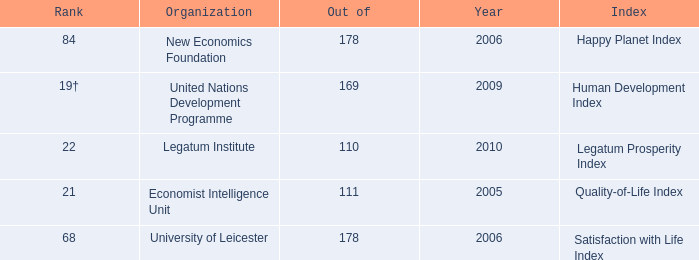What organization ranks 68? University of Leicester. 